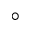<formula> <loc_0><loc_0><loc_500><loc_500>^ { \circ }</formula> 